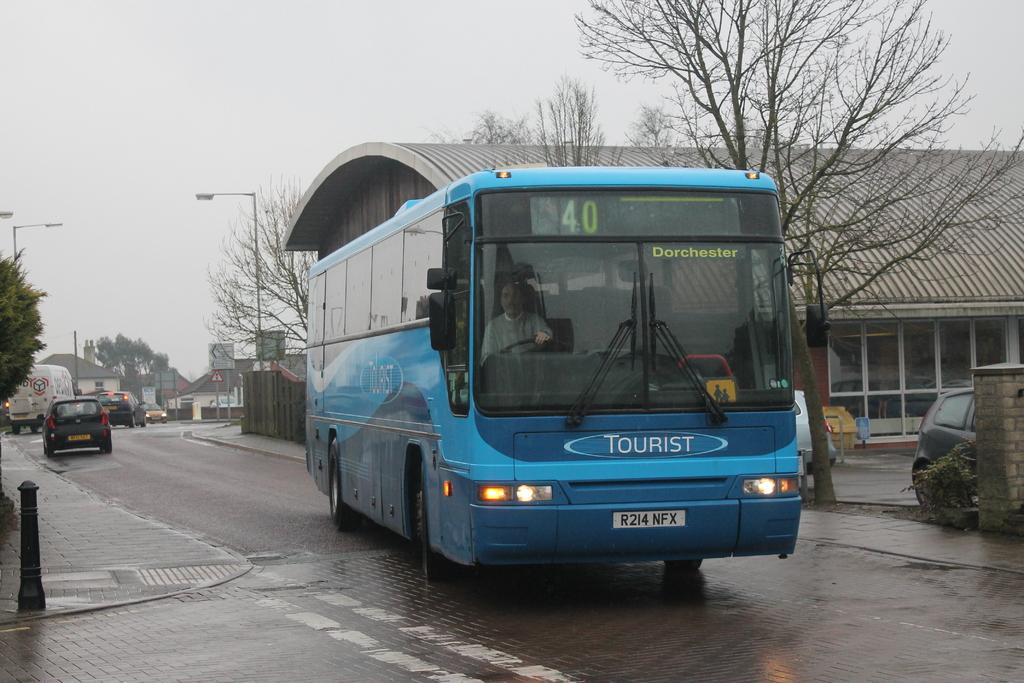<image>
Present a compact description of the photo's key features. A blue tourist bus is on the street on an overcast day. 